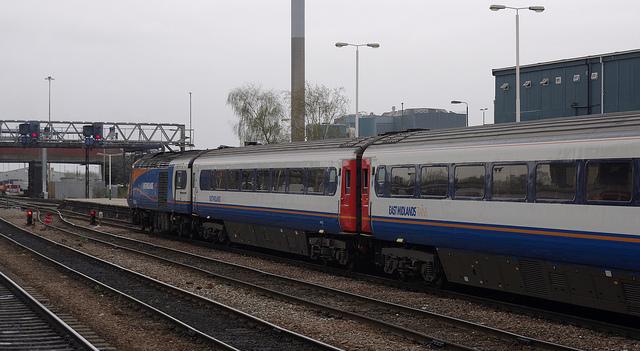Where is platform number 1?
Concise answer only. Behind train. Are all the trains pictured painted the same?
Quick response, please. Yes. What is written on the train?
Write a very short answer. East midlands. What color are the doors on the train?
Short answer required. Red. What is the train doing?
Be succinct. Stopping. What time of day is the picture taken?
Be succinct. Morning. What color are the buildings in the background?
Quick response, please. Blue. 